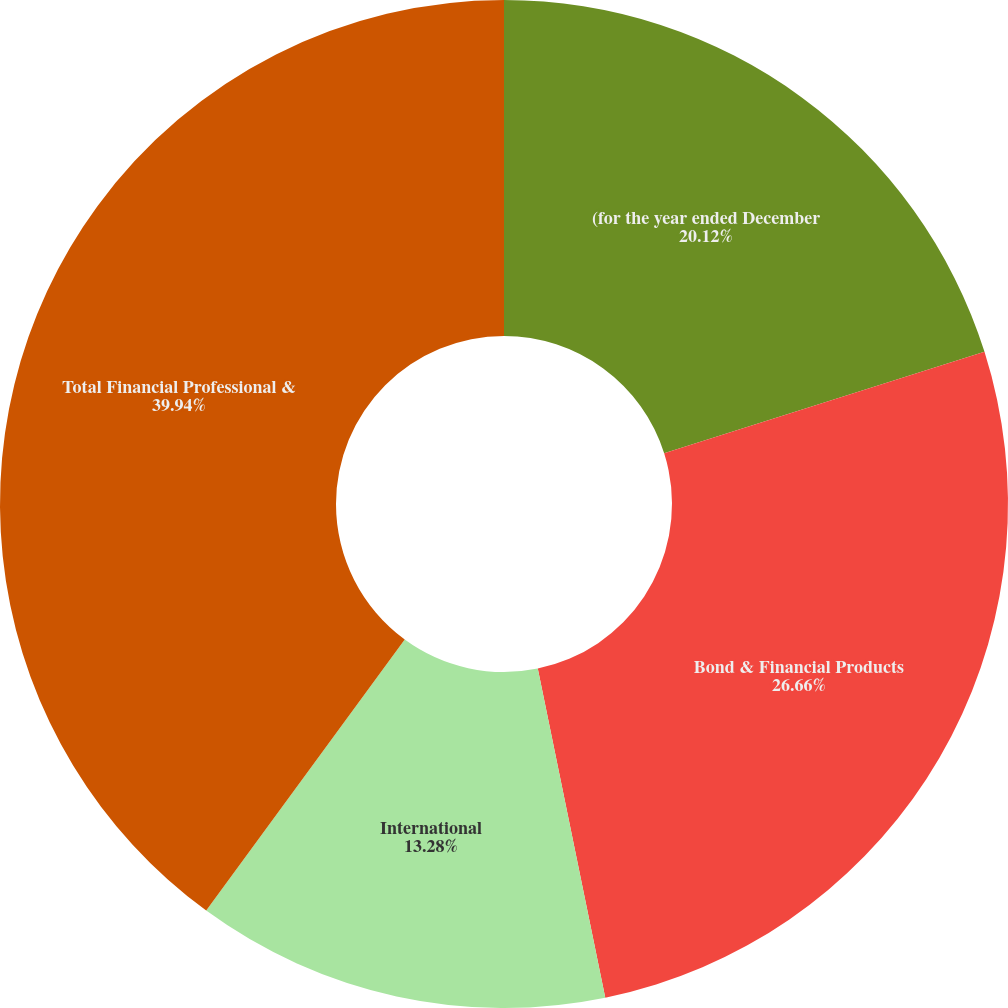<chart> <loc_0><loc_0><loc_500><loc_500><pie_chart><fcel>(for the year ended December<fcel>Bond & Financial Products<fcel>International<fcel>Total Financial Professional &<nl><fcel>20.12%<fcel>26.66%<fcel>13.28%<fcel>39.94%<nl></chart> 